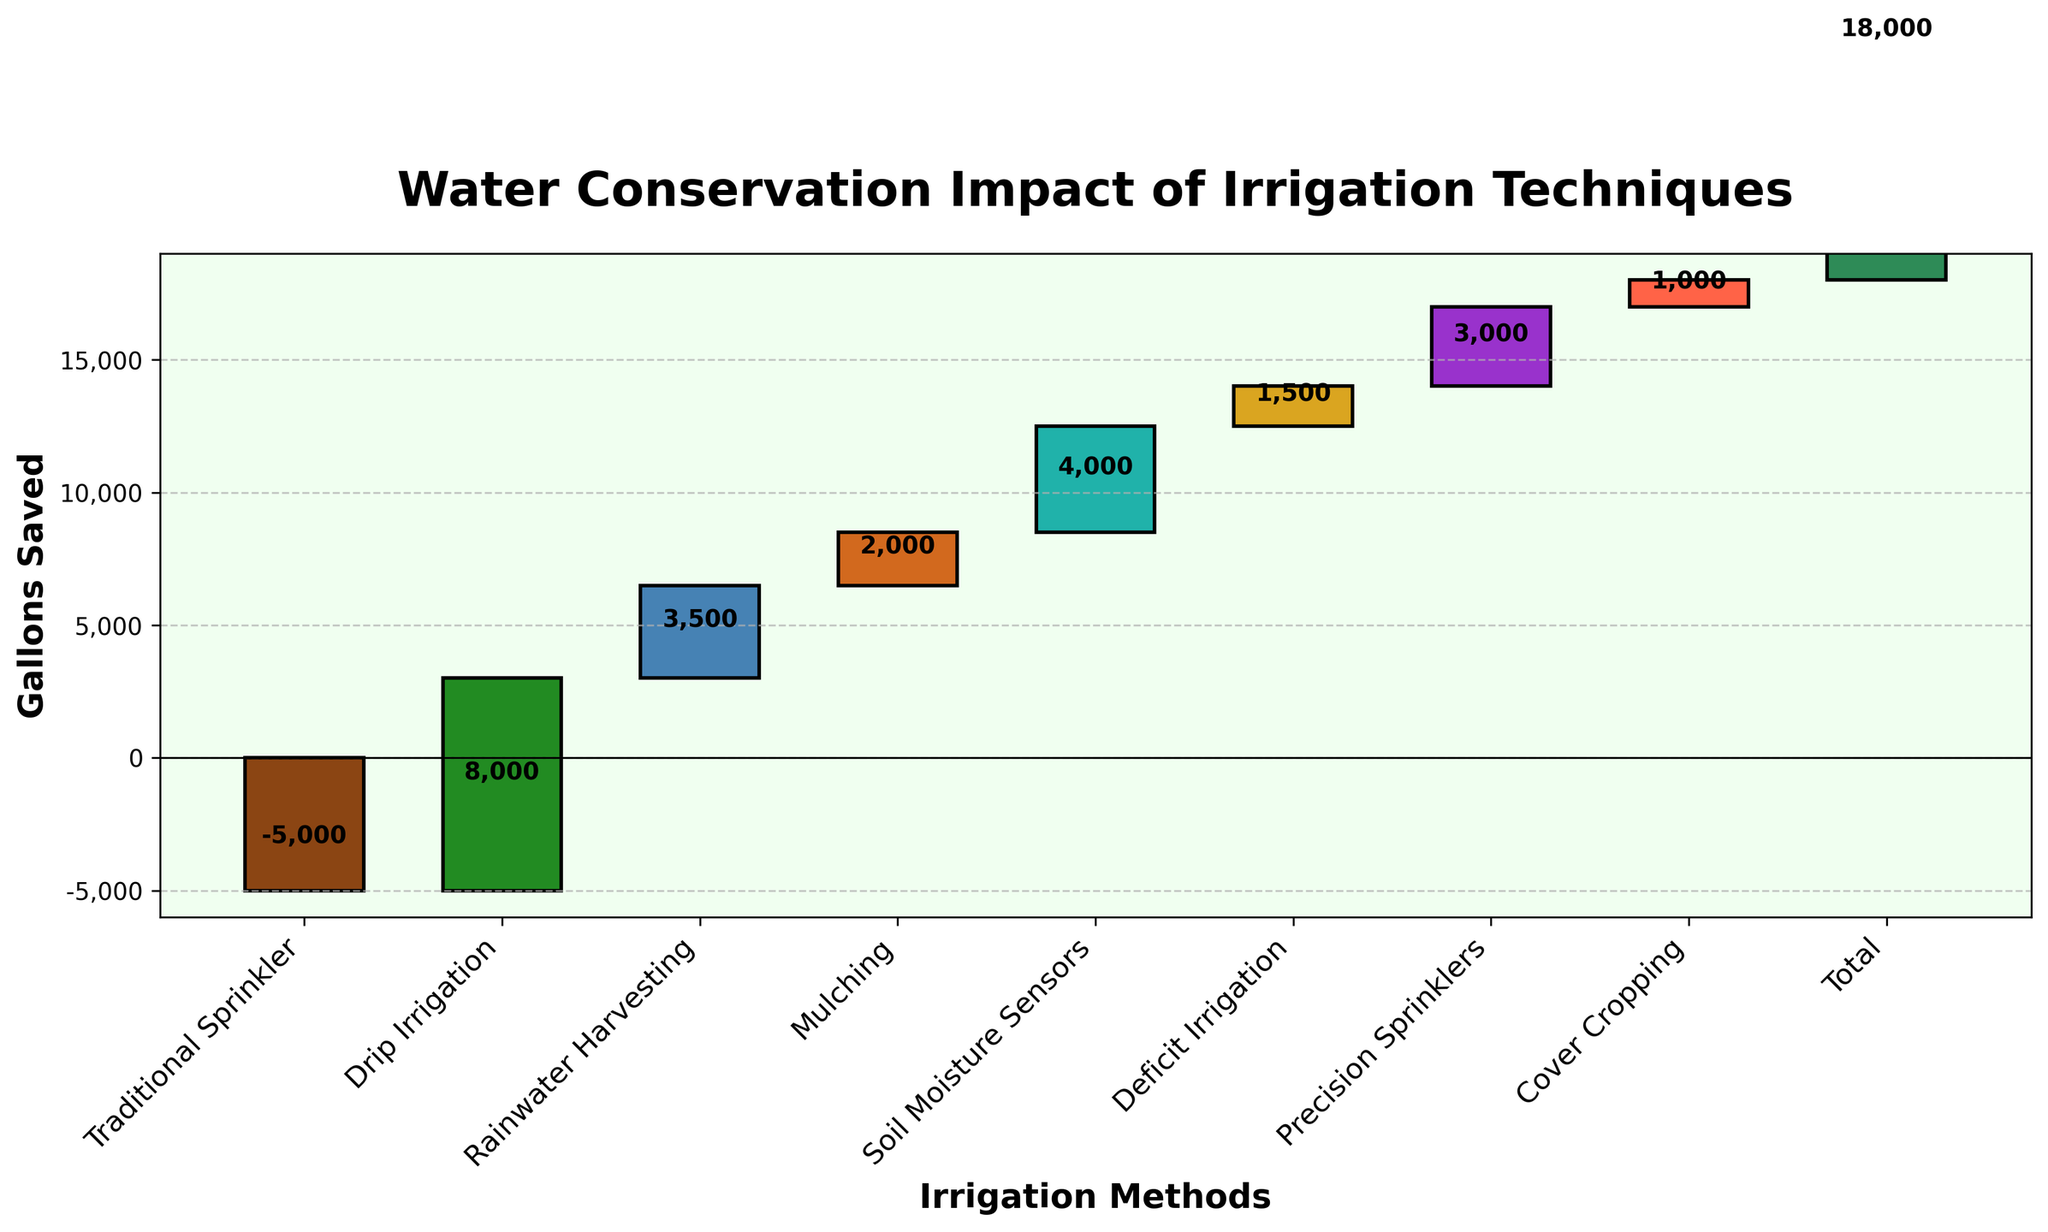What's the title of the plot? The title is usually displayed at the top of the plot and visually stands out. It summarizes the main idea of the graph.
Answer: Water Conservation Impact of Irrigation Techniques How many methods of irrigation are analyzed in the figure? Each bar represents a different method, and the labels on the x-axis denote each method. Count them.
Answer: 8 What is the overall total gallons saved? The last bar on the right is labeled "Total" and shows the combined impact of all methods.
Answer: 18000 gallons Which irrigation technique has the highest positive impact? Look at the heights of the bars; the one with the tallest bar pointing upwards represents the highest positive impact.
Answer: Drip Irrigation Which method resulted in the loss of water? The bar pointing downwards, below the x-axis, indicates a negative impact.
Answer: Traditional Sprinkler How much water is saved by using Soil Moisture Sensors? Find the bar labeled "Soil Moisture Sensors" and check the value associated with it.
Answer: 4000 gallons What is the cumulative water saved by Rainwater Harvesting and Mulching combined? Sum the water saved by both methods as indicated by the height of their respective bars.
Answer: 5500 gallons Which method shows less water conservation when compared to Soil Moisture Sensors? Compare the height of the bars corresponding to different techniques. The ones producing less conservation than Soil Moisture Sensors are shorter.
Answer: Mulching, Deficit Irrigation, Precision Sprinklers, Cover Cropping What are the gallons saved by both Drip Irrigation and Precision Sprinklers? Find these two bars and sum their values.
Answer: 11000 gallons How does the impact of Deficit Irrigation compare to Cover Cropping? Compare the height of the bars for Deficit Irrigation and Cover Cropping to see which one is taller.
Answer: Deficit Irrigation has a higher impact than Cover Cropping 